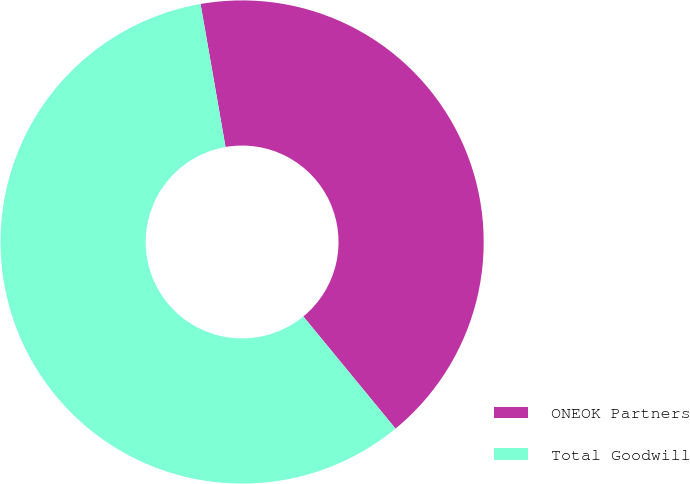Convert chart. <chart><loc_0><loc_0><loc_500><loc_500><pie_chart><fcel>ONEOK Partners<fcel>Total Goodwill<nl><fcel>41.8%<fcel>58.2%<nl></chart> 